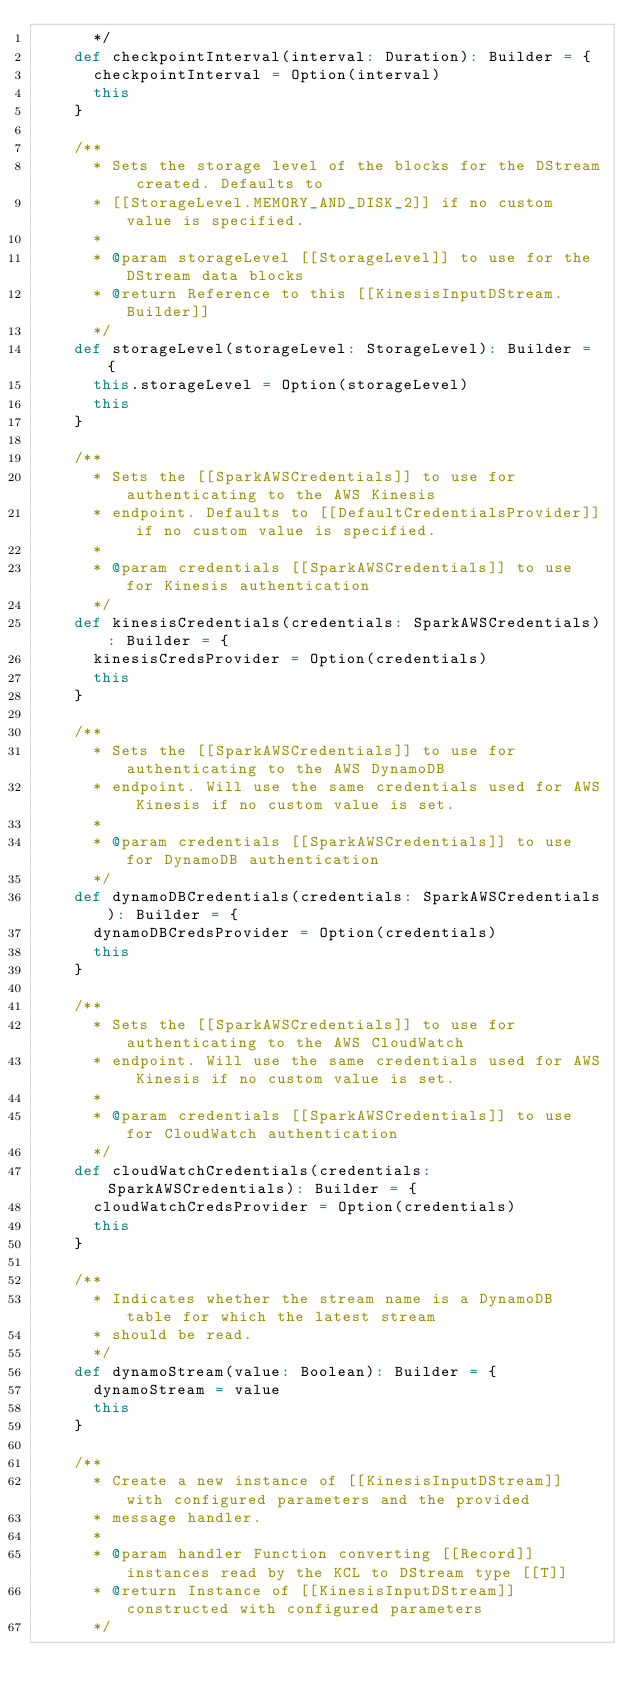Convert code to text. <code><loc_0><loc_0><loc_500><loc_500><_Scala_>      */
    def checkpointInterval(interval: Duration): Builder = {
      checkpointInterval = Option(interval)
      this
    }

    /**
      * Sets the storage level of the blocks for the DStream created. Defaults to
      * [[StorageLevel.MEMORY_AND_DISK_2]] if no custom value is specified.
      *
      * @param storageLevel [[StorageLevel]] to use for the DStream data blocks
      * @return Reference to this [[KinesisInputDStream.Builder]]
      */
    def storageLevel(storageLevel: StorageLevel): Builder = {
      this.storageLevel = Option(storageLevel)
      this
    }

    /**
      * Sets the [[SparkAWSCredentials]] to use for authenticating to the AWS Kinesis
      * endpoint. Defaults to [[DefaultCredentialsProvider]] if no custom value is specified.
      *
      * @param credentials [[SparkAWSCredentials]] to use for Kinesis authentication
      */
    def kinesisCredentials(credentials: SparkAWSCredentials): Builder = {
      kinesisCredsProvider = Option(credentials)
      this
    }

    /**
      * Sets the [[SparkAWSCredentials]] to use for authenticating to the AWS DynamoDB
      * endpoint. Will use the same credentials used for AWS Kinesis if no custom value is set.
      *
      * @param credentials [[SparkAWSCredentials]] to use for DynamoDB authentication
      */
    def dynamoDBCredentials(credentials: SparkAWSCredentials): Builder = {
      dynamoDBCredsProvider = Option(credentials)
      this
    }

    /**
      * Sets the [[SparkAWSCredentials]] to use for authenticating to the AWS CloudWatch
      * endpoint. Will use the same credentials used for AWS Kinesis if no custom value is set.
      *
      * @param credentials [[SparkAWSCredentials]] to use for CloudWatch authentication
      */
    def cloudWatchCredentials(credentials: SparkAWSCredentials): Builder = {
      cloudWatchCredsProvider = Option(credentials)
      this
    }

    /**
      * Indicates whether the stream name is a DynamoDB table for which the latest stream
      * should be read.
      */
    def dynamoStream(value: Boolean): Builder = {
      dynamoStream = value
      this
    }

    /**
      * Create a new instance of [[KinesisInputDStream]] with configured parameters and the provided
      * message handler.
      *
      * @param handler Function converting [[Record]] instances read by the KCL to DStream type [[T]]
      * @return Instance of [[KinesisInputDStream]] constructed with configured parameters
      */</code> 